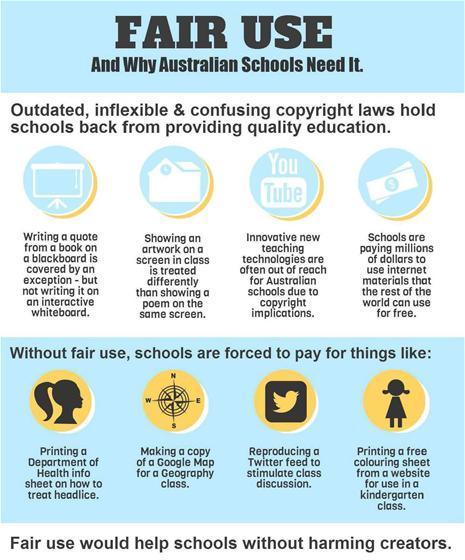Outline some significant characteristics in this image. The reason why innovative new teaching technologies are often out of reach for Australian schools is due to copyright implications. The rest of the world is free to use internet materials. 